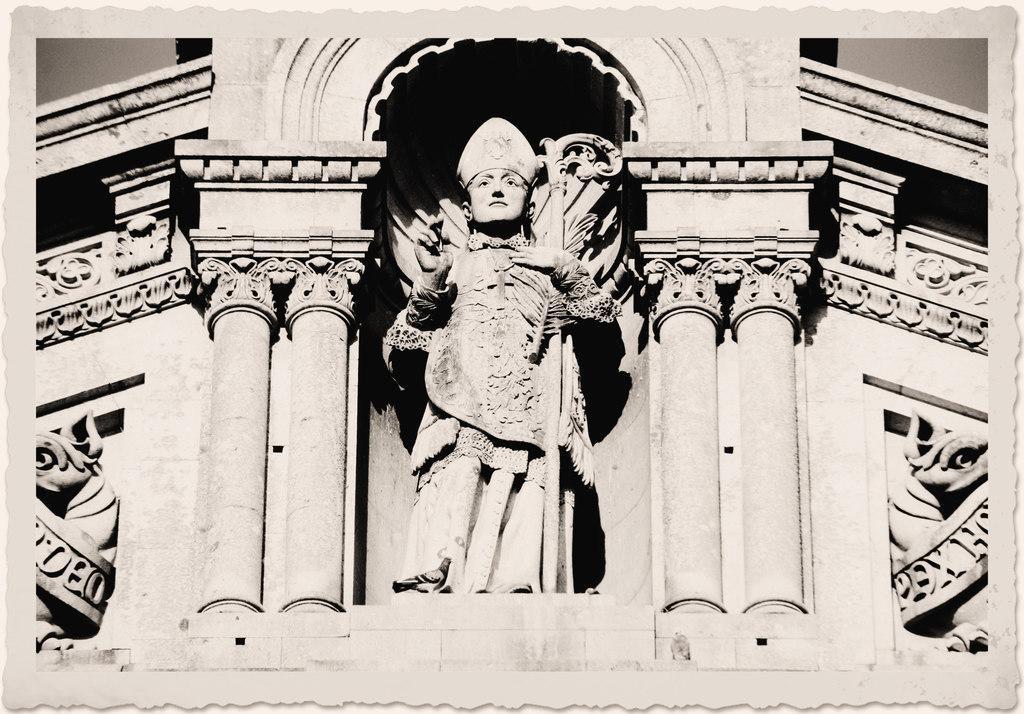Could you give a brief overview of what you see in this image? In this picture I can see sculpture to the building. 